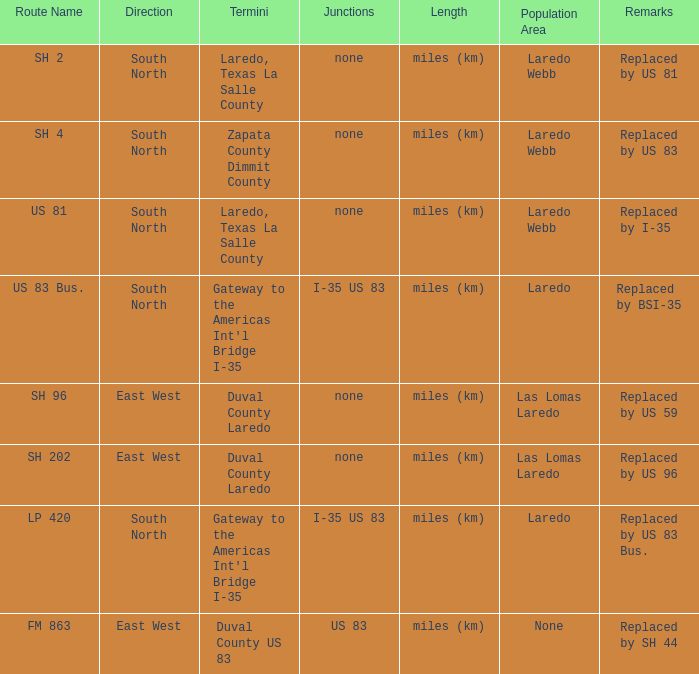Which junctions have "replaced by bsi-35" listed in their remarks section? I-35 US 83. 